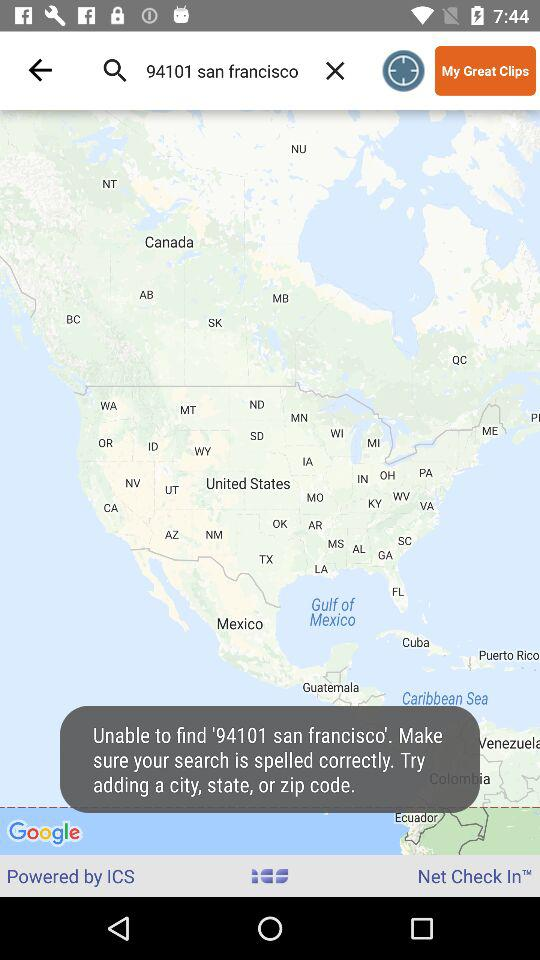What was the search location? The search location was San Francisco, 94101. 